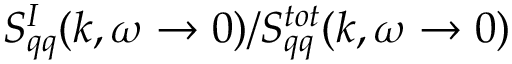Convert formula to latex. <formula><loc_0><loc_0><loc_500><loc_500>S _ { q q } ^ { I } ( k , \omega \to 0 ) / S _ { q q } ^ { t o t } ( k , \omega \to 0 )</formula> 